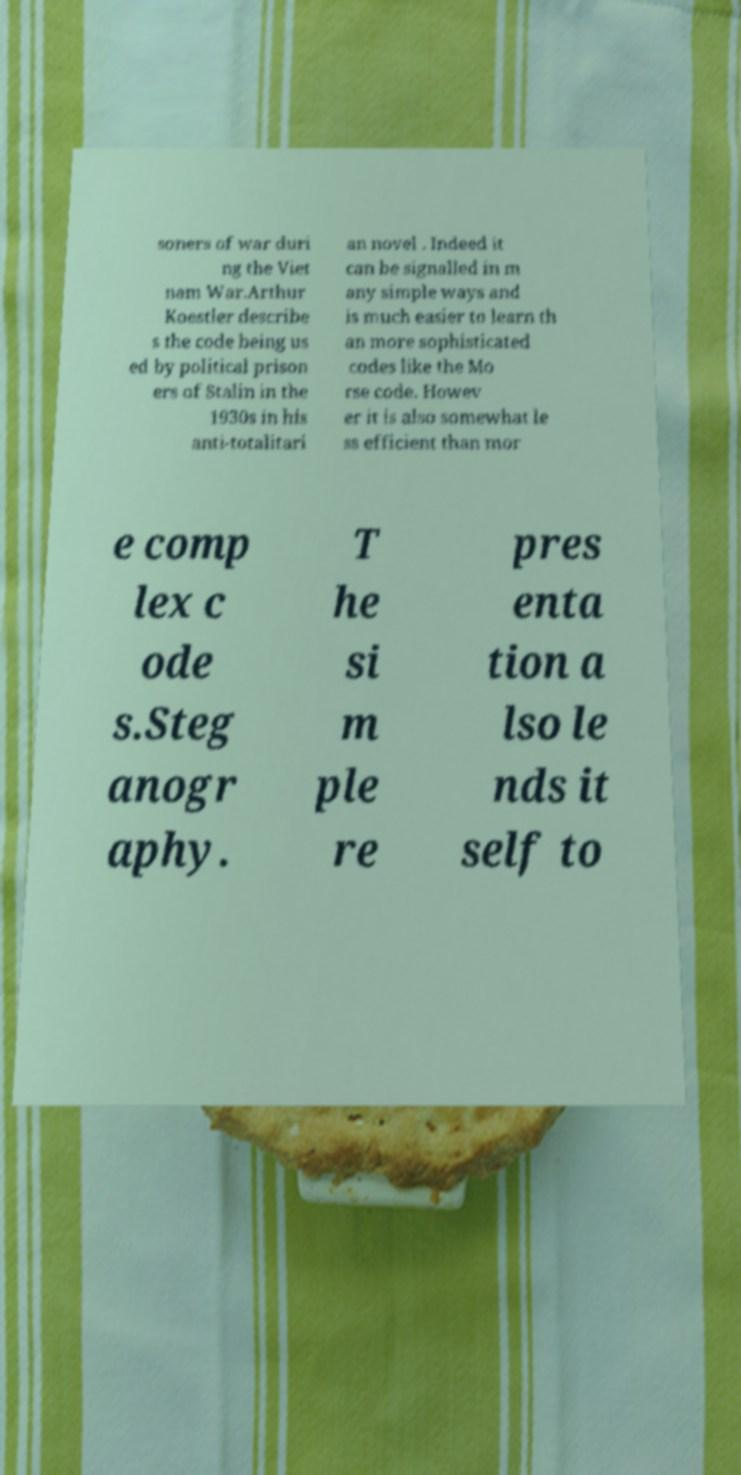There's text embedded in this image that I need extracted. Can you transcribe it verbatim? soners of war duri ng the Viet nam War.Arthur Koestler describe s the code being us ed by political prison ers of Stalin in the 1930s in his anti-totalitari an novel . Indeed it can be signalled in m any simple ways and is much easier to learn th an more sophisticated codes like the Mo rse code. Howev er it is also somewhat le ss efficient than mor e comp lex c ode s.Steg anogr aphy. T he si m ple re pres enta tion a lso le nds it self to 